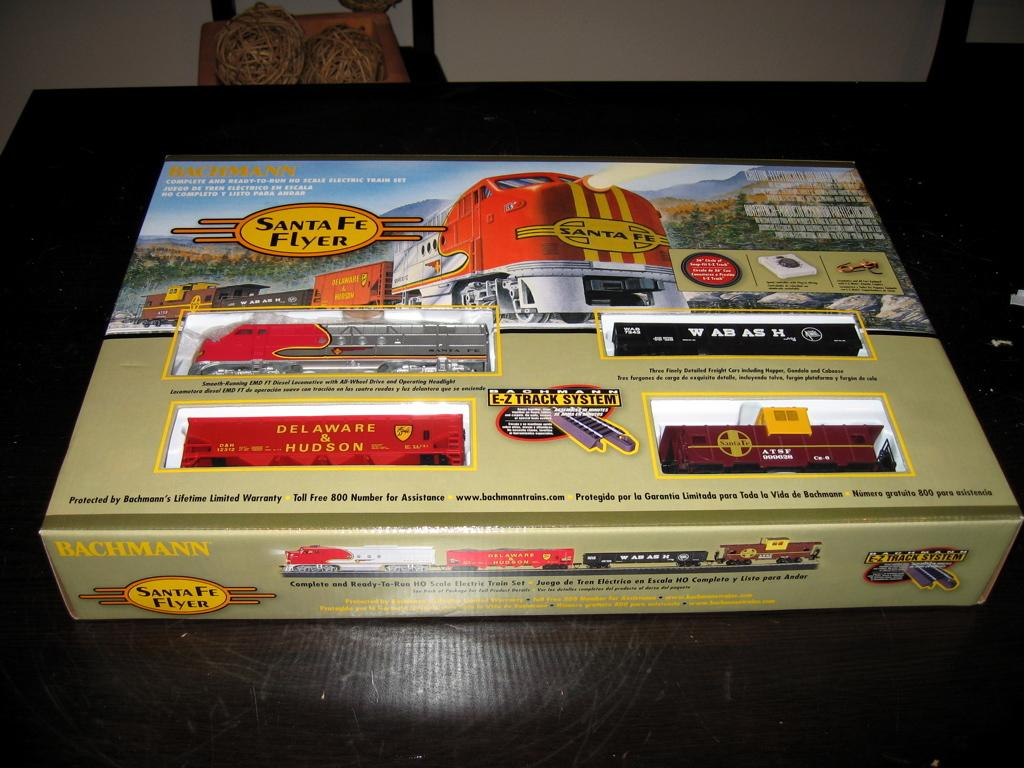What object is present in the image that is used for storing toys? There is a toy box in the image. Where is the toy box located? The toy box is placed on a table. What is the color of the table top? The table top is black in color. What can be seen in the background of the image? There is a white color wall in the background of the image. How many apples are on the table next to the toy box? There are no apples present in the image; the focus is on the toy box and the table. 